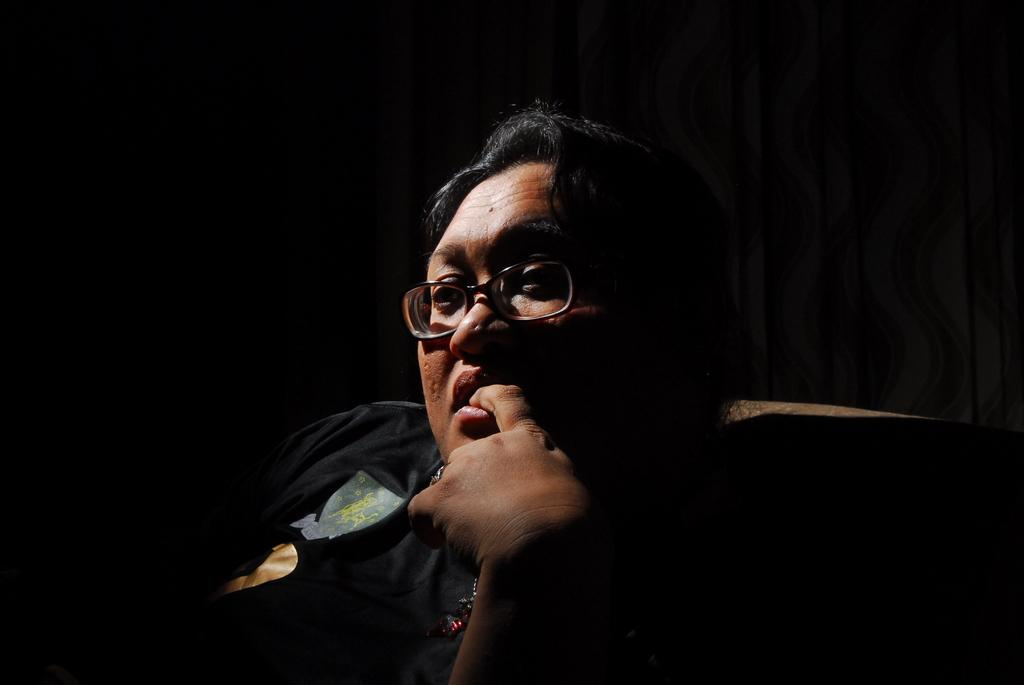What is the main subject of the image? There is a person in the image. What can be observed about the person's appearance? The person is wearing spectacles. What is the person doing in the image? The person is sitting on a chair. What can be inferred about the lighting conditions in the image? The background of the image is dark. What type of popcorn is being served in the image? There is no popcorn present in the image. What fact can be learned about society from the image? The image does not provide any information about society, as it only features a person sitting on a chair. 